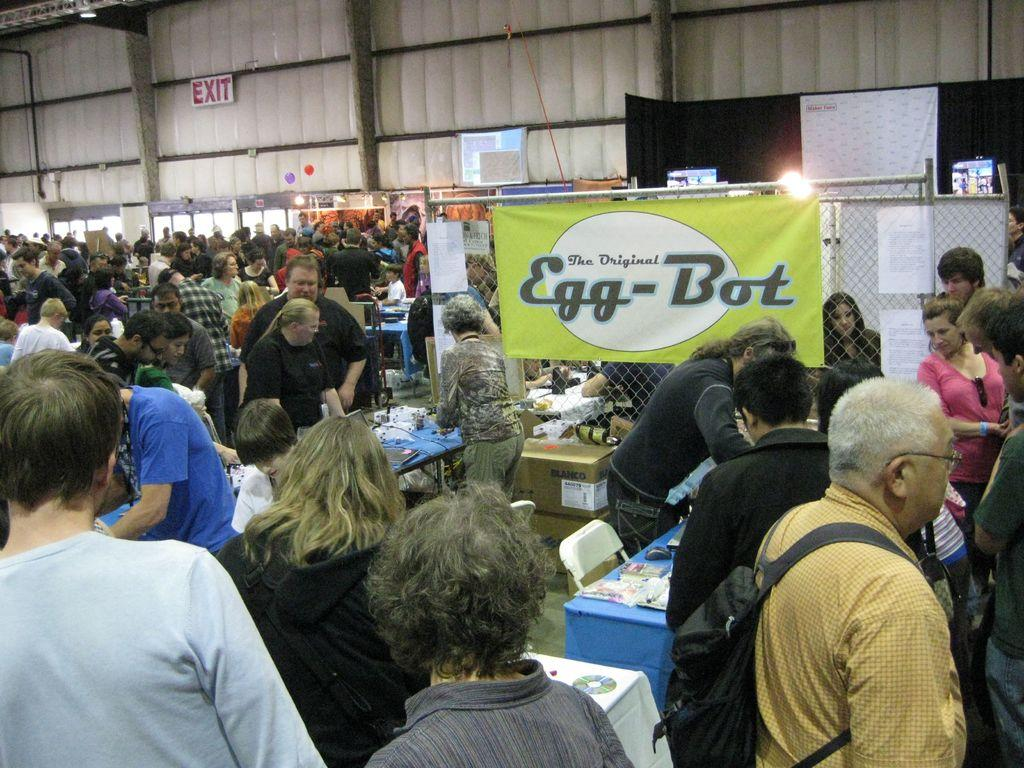How many people are in the image? There is a group of people in the image, but the exact number is not specified. What are the people doing in the image? The people are standing beside tables in the image. What can be seen on the fence in the image? There is a banner on a fence in the image. What is visible in the background of the image? There is a wall in the background of the image. Are there any insects flying around the people in the image? There is no mention of insects in the image, so it cannot be determined if any are present. 